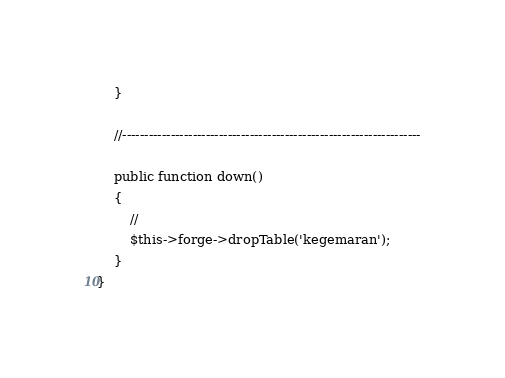<code> <loc_0><loc_0><loc_500><loc_500><_PHP_>	}

	//--------------------------------------------------------------------

	public function down()
	{
		//
		$this->forge->dropTable('kegemaran');
	}
}
</code> 